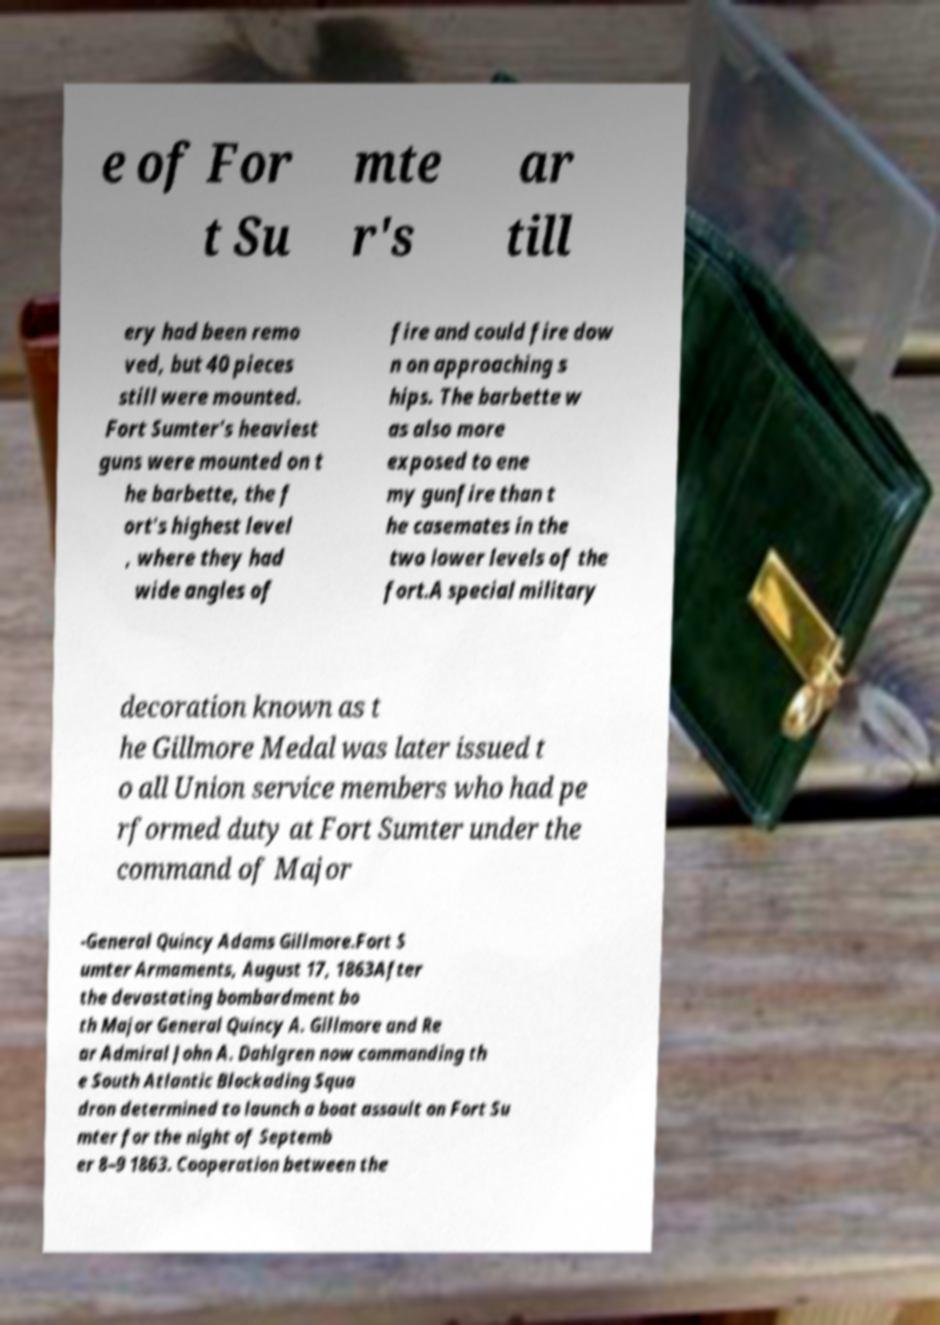Can you read and provide the text displayed in the image?This photo seems to have some interesting text. Can you extract and type it out for me? e of For t Su mte r's ar till ery had been remo ved, but 40 pieces still were mounted. Fort Sumter's heaviest guns were mounted on t he barbette, the f ort's highest level , where they had wide angles of fire and could fire dow n on approaching s hips. The barbette w as also more exposed to ene my gunfire than t he casemates in the two lower levels of the fort.A special military decoration known as t he Gillmore Medal was later issued t o all Union service members who had pe rformed duty at Fort Sumter under the command of Major -General Quincy Adams Gillmore.Fort S umter Armaments, August 17, 1863After the devastating bombardment bo th Major General Quincy A. Gillmore and Re ar Admiral John A. Dahlgren now commanding th e South Atlantic Blockading Squa dron determined to launch a boat assault on Fort Su mter for the night of Septemb er 8–9 1863. Cooperation between the 